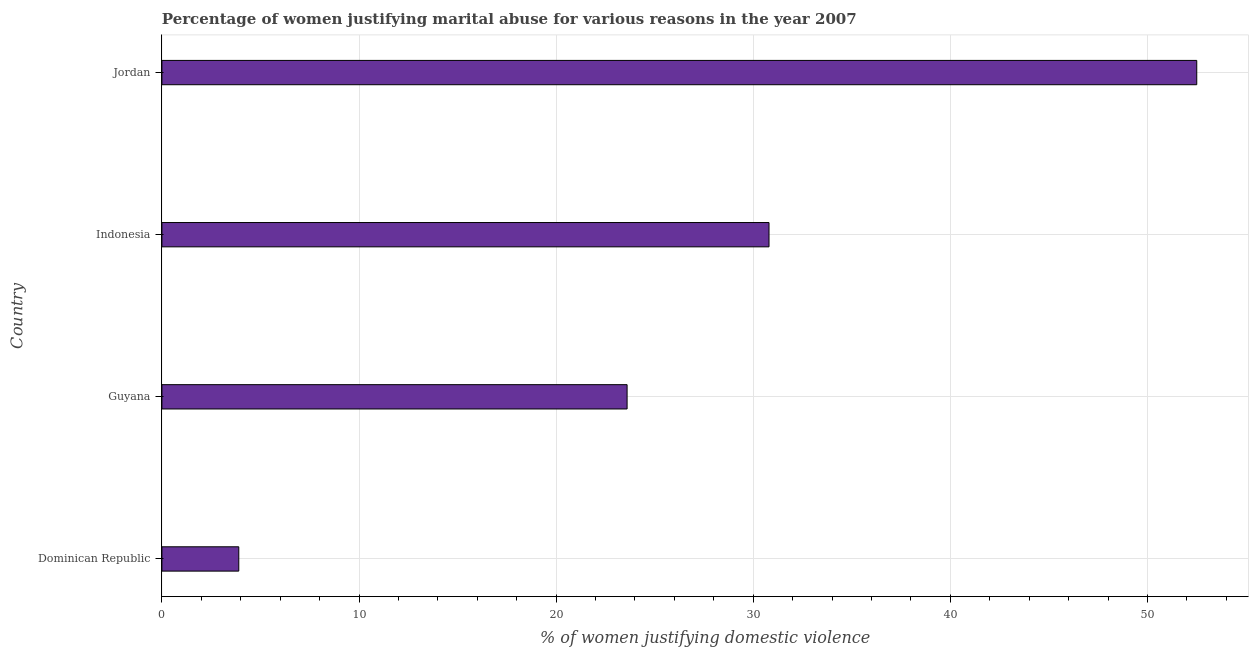Does the graph contain grids?
Your answer should be compact. Yes. What is the title of the graph?
Provide a succinct answer. Percentage of women justifying marital abuse for various reasons in the year 2007. What is the label or title of the X-axis?
Provide a succinct answer. % of women justifying domestic violence. Across all countries, what is the maximum percentage of women justifying marital abuse?
Keep it short and to the point. 52.5. Across all countries, what is the minimum percentage of women justifying marital abuse?
Your answer should be very brief. 3.9. In which country was the percentage of women justifying marital abuse maximum?
Offer a very short reply. Jordan. In which country was the percentage of women justifying marital abuse minimum?
Make the answer very short. Dominican Republic. What is the sum of the percentage of women justifying marital abuse?
Your response must be concise. 110.8. What is the difference between the percentage of women justifying marital abuse in Dominican Republic and Guyana?
Provide a short and direct response. -19.7. What is the average percentage of women justifying marital abuse per country?
Ensure brevity in your answer.  27.7. What is the median percentage of women justifying marital abuse?
Make the answer very short. 27.2. What is the ratio of the percentage of women justifying marital abuse in Guyana to that in Indonesia?
Your answer should be compact. 0.77. What is the difference between the highest and the second highest percentage of women justifying marital abuse?
Give a very brief answer. 21.7. Is the sum of the percentage of women justifying marital abuse in Dominican Republic and Indonesia greater than the maximum percentage of women justifying marital abuse across all countries?
Your answer should be very brief. No. What is the difference between the highest and the lowest percentage of women justifying marital abuse?
Your answer should be very brief. 48.6. Are all the bars in the graph horizontal?
Offer a very short reply. Yes. How many countries are there in the graph?
Offer a terse response. 4. What is the difference between two consecutive major ticks on the X-axis?
Your answer should be compact. 10. Are the values on the major ticks of X-axis written in scientific E-notation?
Ensure brevity in your answer.  No. What is the % of women justifying domestic violence of Guyana?
Provide a succinct answer. 23.6. What is the % of women justifying domestic violence of Indonesia?
Ensure brevity in your answer.  30.8. What is the % of women justifying domestic violence of Jordan?
Keep it short and to the point. 52.5. What is the difference between the % of women justifying domestic violence in Dominican Republic and Guyana?
Provide a succinct answer. -19.7. What is the difference between the % of women justifying domestic violence in Dominican Republic and Indonesia?
Your response must be concise. -26.9. What is the difference between the % of women justifying domestic violence in Dominican Republic and Jordan?
Your response must be concise. -48.6. What is the difference between the % of women justifying domestic violence in Guyana and Indonesia?
Make the answer very short. -7.2. What is the difference between the % of women justifying domestic violence in Guyana and Jordan?
Your answer should be compact. -28.9. What is the difference between the % of women justifying domestic violence in Indonesia and Jordan?
Your answer should be very brief. -21.7. What is the ratio of the % of women justifying domestic violence in Dominican Republic to that in Guyana?
Offer a terse response. 0.17. What is the ratio of the % of women justifying domestic violence in Dominican Republic to that in Indonesia?
Offer a terse response. 0.13. What is the ratio of the % of women justifying domestic violence in Dominican Republic to that in Jordan?
Your response must be concise. 0.07. What is the ratio of the % of women justifying domestic violence in Guyana to that in Indonesia?
Give a very brief answer. 0.77. What is the ratio of the % of women justifying domestic violence in Guyana to that in Jordan?
Ensure brevity in your answer.  0.45. What is the ratio of the % of women justifying domestic violence in Indonesia to that in Jordan?
Make the answer very short. 0.59. 